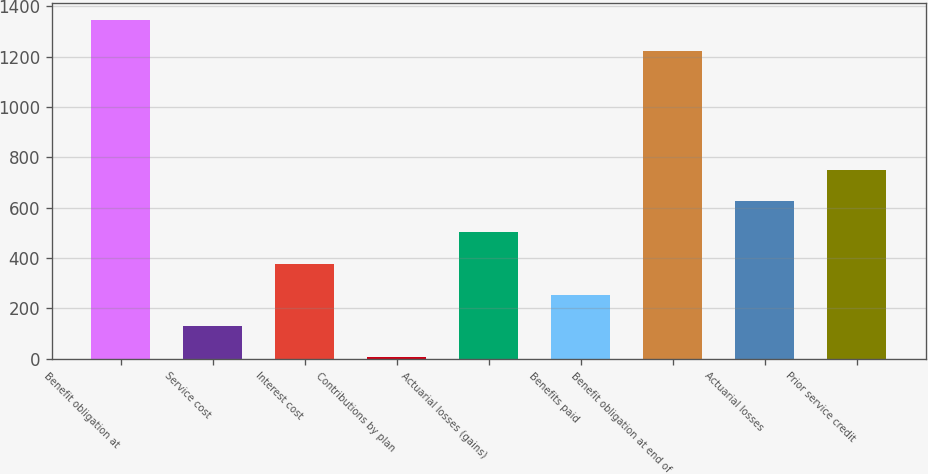<chart> <loc_0><loc_0><loc_500><loc_500><bar_chart><fcel>Benefit obligation at<fcel>Service cost<fcel>Interest cost<fcel>Contributions by plan<fcel>Actuarial losses (gains)<fcel>Benefits paid<fcel>Benefit obligation at end of<fcel>Actuarial losses<fcel>Prior service credit<nl><fcel>1345.1<fcel>130.1<fcel>378.3<fcel>6<fcel>502.4<fcel>254.2<fcel>1221<fcel>626.5<fcel>750.6<nl></chart> 